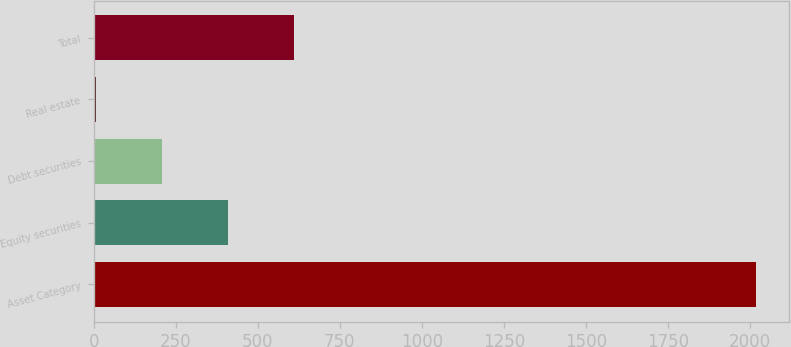Convert chart. <chart><loc_0><loc_0><loc_500><loc_500><bar_chart><fcel>Asset Category<fcel>Equity securities<fcel>Debt securities<fcel>Real estate<fcel>Total<nl><fcel>2017<fcel>409<fcel>208<fcel>7<fcel>610<nl></chart> 